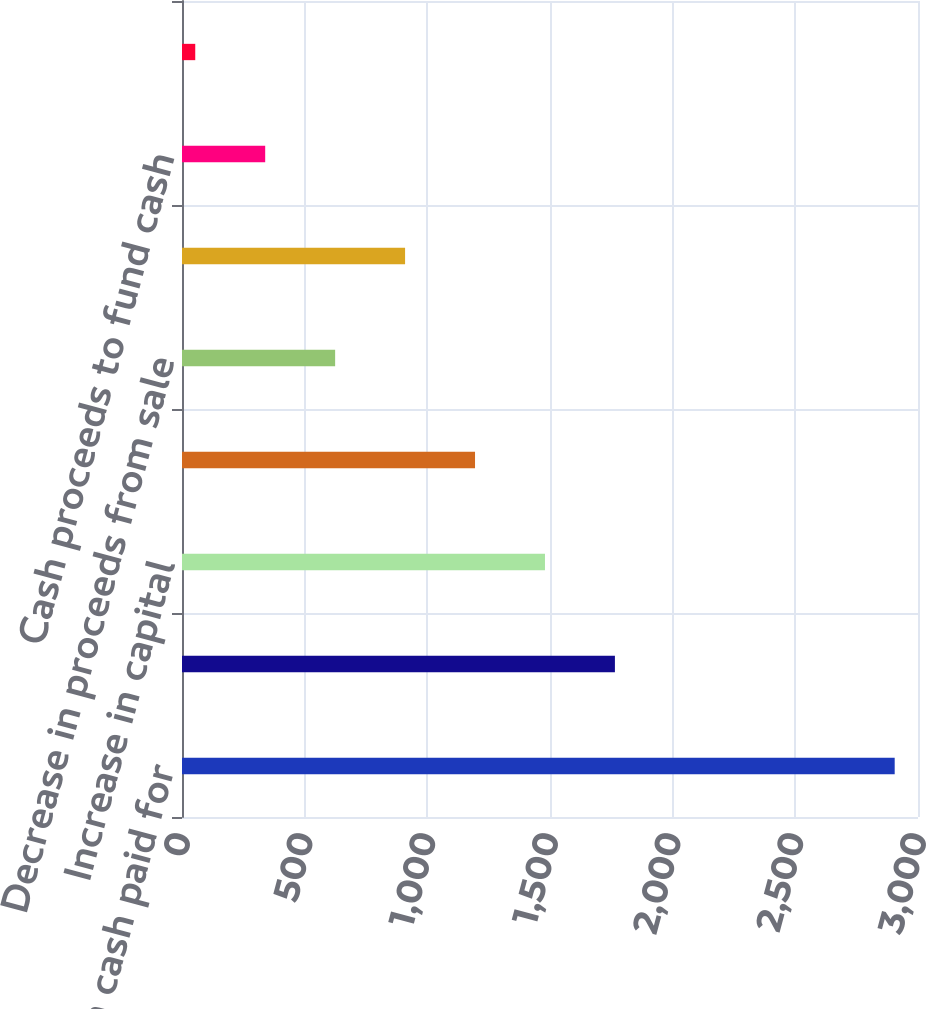Convert chart. <chart><loc_0><loc_0><loc_500><loc_500><bar_chart><fcel>Decrease in cash paid for<fcel>Decrease in cash grants<fcel>Increase in capital<fcel>Increase in equity investments<fcel>Decrease in proceeds from sale<fcel>Decrease in restricted cash<fcel>Cash proceeds to fund cash<fcel>Other<nl><fcel>2905<fcel>1764.6<fcel>1479.5<fcel>1194.4<fcel>624.2<fcel>909.3<fcel>339.1<fcel>54<nl></chart> 